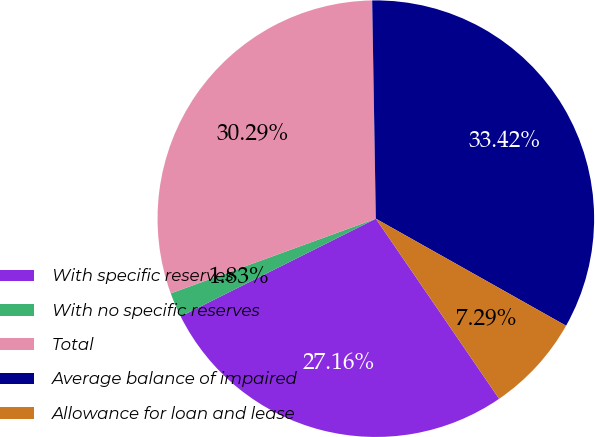Convert chart. <chart><loc_0><loc_0><loc_500><loc_500><pie_chart><fcel>With specific reserves<fcel>With no specific reserves<fcel>Total<fcel>Average balance of impaired<fcel>Allowance for loan and lease<nl><fcel>27.16%<fcel>1.83%<fcel>30.29%<fcel>33.42%<fcel>7.29%<nl></chart> 